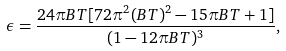Convert formula to latex. <formula><loc_0><loc_0><loc_500><loc_500>\epsilon = \frac { 2 4 \pi B T [ 7 2 \pi ^ { 2 } ( B T ) ^ { 2 } - 1 5 \pi B T + 1 ] } { ( 1 - 1 2 \pi B T ) ^ { 3 } } ,</formula> 